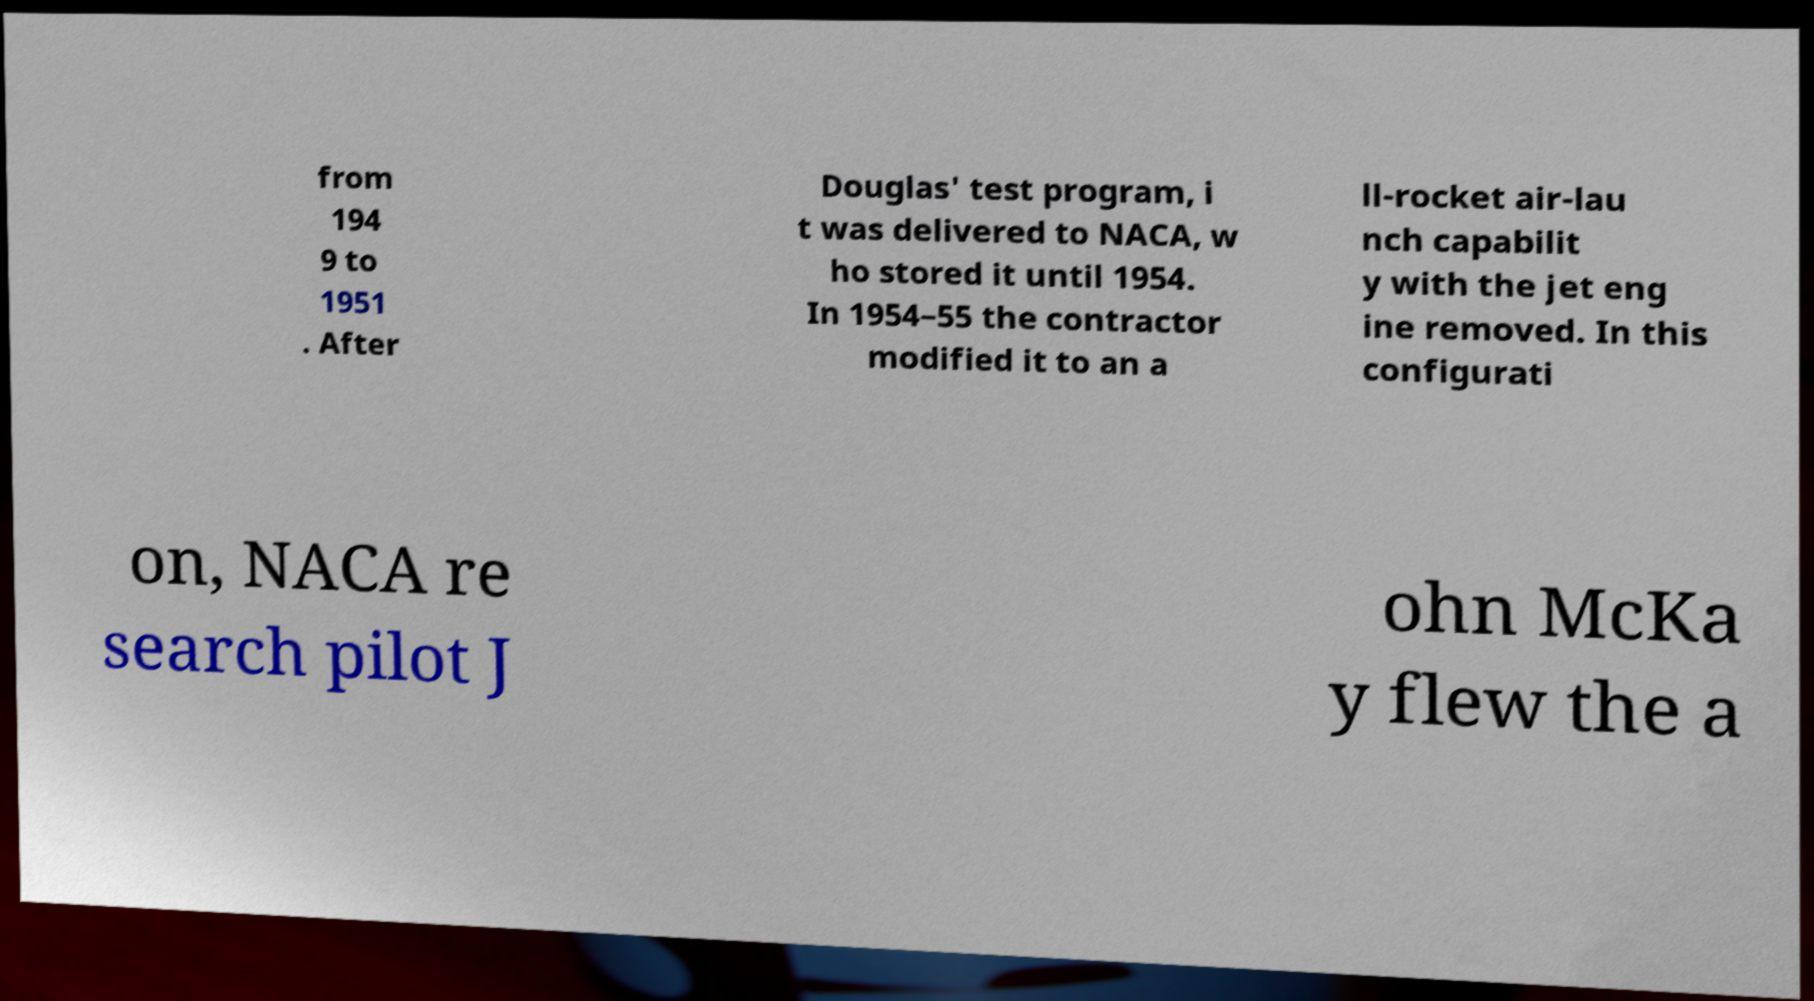Can you accurately transcribe the text from the provided image for me? from 194 9 to 1951 . After Douglas' test program, i t was delivered to NACA, w ho stored it until 1954. In 1954–55 the contractor modified it to an a ll-rocket air-lau nch capabilit y with the jet eng ine removed. In this configurati on, NACA re search pilot J ohn McKa y flew the a 